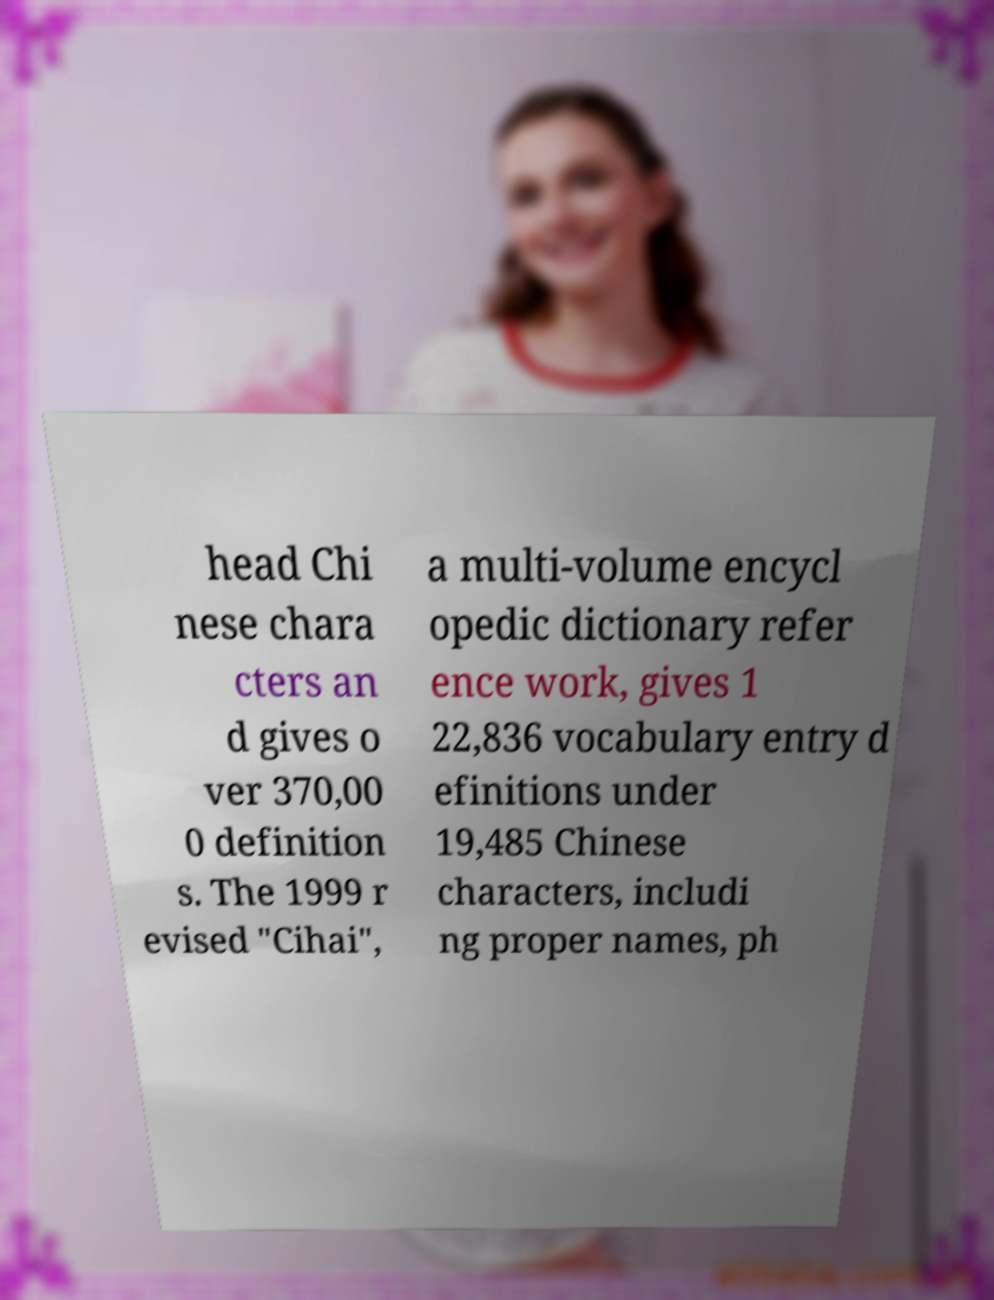There's text embedded in this image that I need extracted. Can you transcribe it verbatim? head Chi nese chara cters an d gives o ver 370,00 0 definition s. The 1999 r evised "Cihai", a multi-volume encycl opedic dictionary refer ence work, gives 1 22,836 vocabulary entry d efinitions under 19,485 Chinese characters, includi ng proper names, ph 